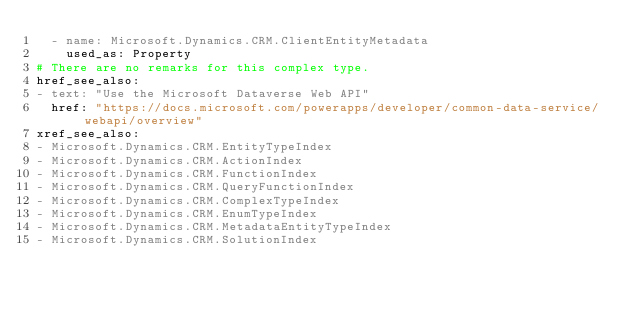<code> <loc_0><loc_0><loc_500><loc_500><_YAML_>  - name: Microsoft.Dynamics.CRM.ClientEntityMetadata
    used_as: Property
# There are no remarks for this complex type.
href_see_also:
- text: "Use the Microsoft Dataverse Web API"
  href: "https://docs.microsoft.com/powerapps/developer/common-data-service/webapi/overview"
xref_see_also:
- Microsoft.Dynamics.CRM.EntityTypeIndex
- Microsoft.Dynamics.CRM.ActionIndex
- Microsoft.Dynamics.CRM.FunctionIndex
- Microsoft.Dynamics.CRM.QueryFunctionIndex
- Microsoft.Dynamics.CRM.ComplexTypeIndex
- Microsoft.Dynamics.CRM.EnumTypeIndex
- Microsoft.Dynamics.CRM.MetadataEntityTypeIndex
- Microsoft.Dynamics.CRM.SolutionIndex
</code> 